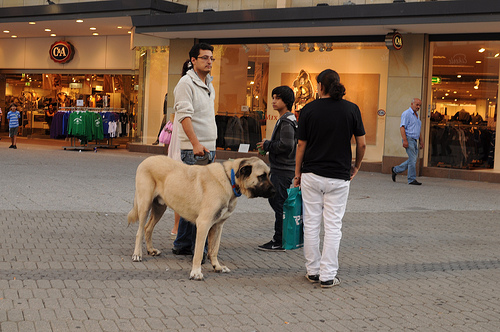Who is wearing a shirt? The woman in the scene is wearing a shirt, distinctively dressed compared to others in the image. 